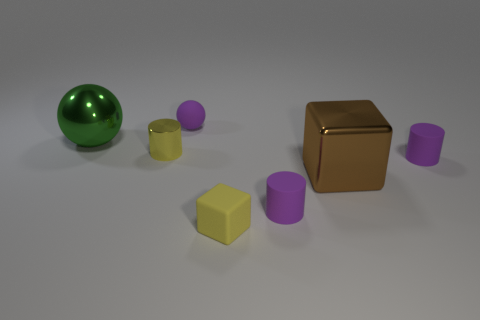Add 3 big green metallic balls. How many objects exist? 10 Subtract all blocks. How many objects are left? 5 Add 4 big green things. How many big green things are left? 5 Add 6 small yellow matte things. How many small yellow matte things exist? 7 Subtract 0 blue cubes. How many objects are left? 7 Subtract all tiny shiny spheres. Subtract all tiny yellow objects. How many objects are left? 5 